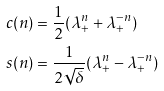Convert formula to latex. <formula><loc_0><loc_0><loc_500><loc_500>c ( n ) & = \frac { 1 } { 2 } ( \lambda _ { + } ^ { n } + \lambda _ { + } ^ { - n } ) \\ s ( n ) & = \frac { 1 } { 2 \sqrt { \delta } } ( \lambda _ { + } ^ { n } - \lambda _ { + } ^ { - n } )</formula> 